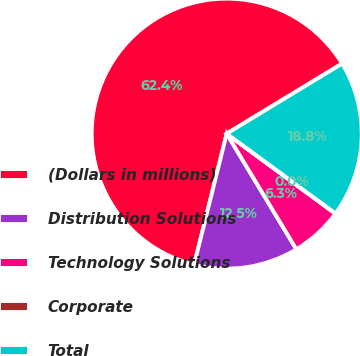Convert chart. <chart><loc_0><loc_0><loc_500><loc_500><pie_chart><fcel>(Dollars in millions)<fcel>Distribution Solutions<fcel>Technology Solutions<fcel>Corporate<fcel>Total<nl><fcel>62.43%<fcel>12.51%<fcel>6.27%<fcel>0.03%<fcel>18.75%<nl></chart> 